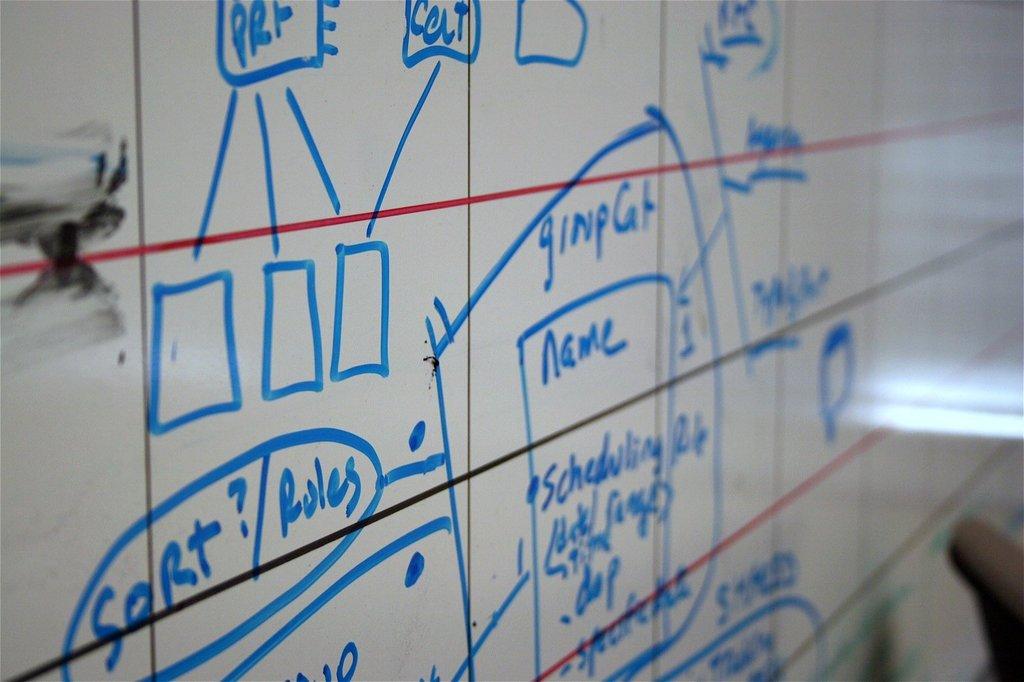What comes after sort?
Keep it short and to the point. Rules. What does it say after the first word on top?
Keep it short and to the point. Colt. 